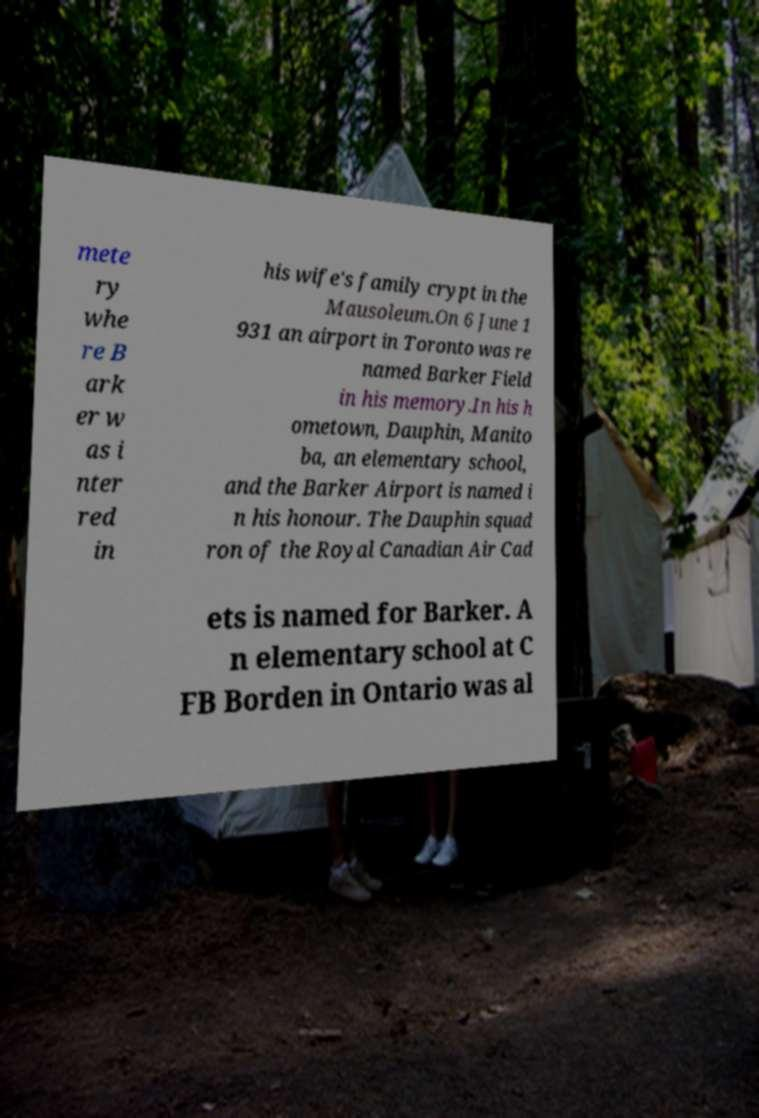Please identify and transcribe the text found in this image. mete ry whe re B ark er w as i nter red in his wife's family crypt in the Mausoleum.On 6 June 1 931 an airport in Toronto was re named Barker Field in his memory.In his h ometown, Dauphin, Manito ba, an elementary school, and the Barker Airport is named i n his honour. The Dauphin squad ron of the Royal Canadian Air Cad ets is named for Barker. A n elementary school at C FB Borden in Ontario was al 